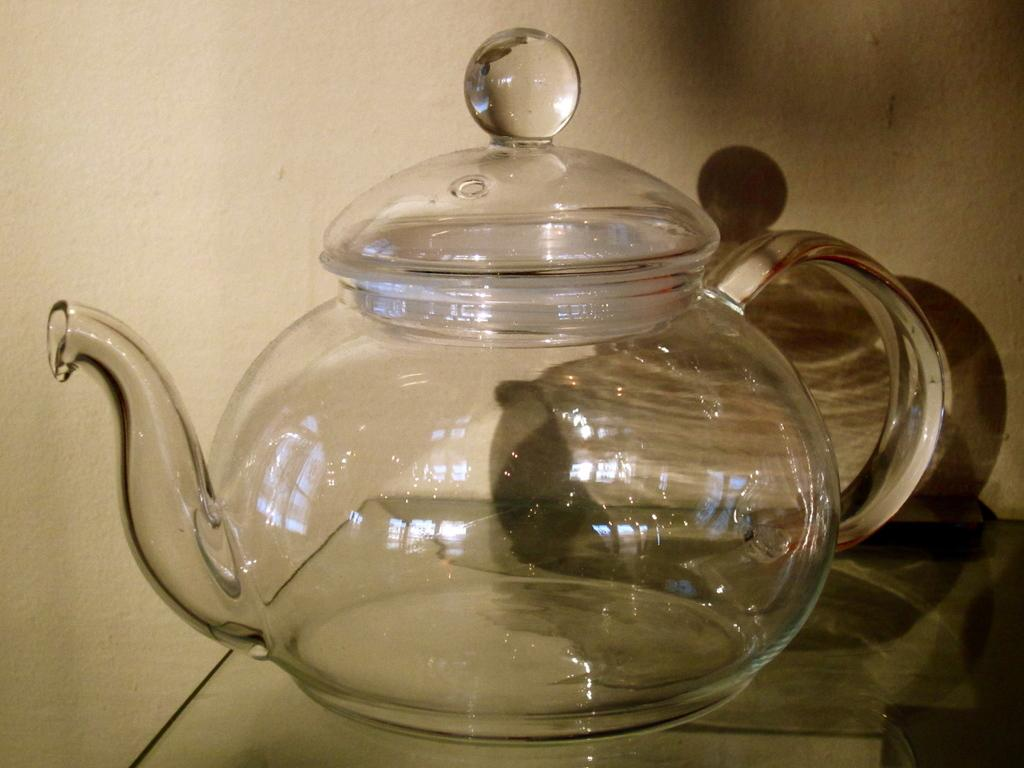What is the main object in the middle of the image? There is a teapot in the middle of the image. What type of camera is used to take the picture of the stew in the image? There is no camera or stew present in the image; it only features a teapot. What record is being played in the background of the image? There is no record or indication of music in the image; it only features a teapot. 